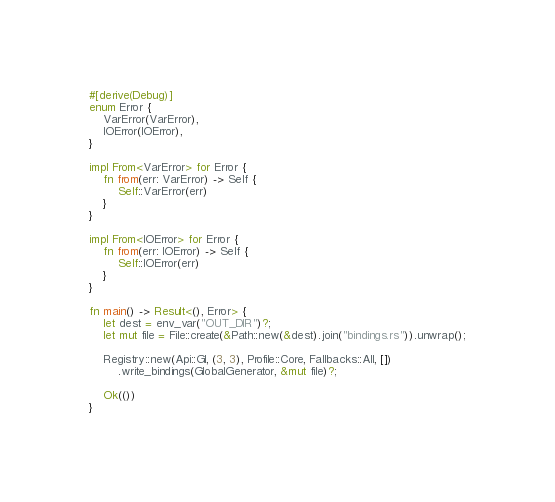<code> <loc_0><loc_0><loc_500><loc_500><_Rust_>#[derive(Debug)]
enum Error {
    VarError(VarError),
    IOError(IOError),
}

impl From<VarError> for Error {
    fn from(err: VarError) -> Self {
        Self::VarError(err)
    }
}

impl From<IOError> for Error {
    fn from(err: IOError) -> Self {
        Self::IOError(err)
    }
}

fn main() -> Result<(), Error> {
    let dest = env_var("OUT_DIR")?;
    let mut file = File::create(&Path::new(&dest).join("bindings.rs")).unwrap();

    Registry::new(Api::Gl, (3, 3), Profile::Core, Fallbacks::All, [])
        .write_bindings(GlobalGenerator, &mut file)?;

    Ok(())
}
</code> 